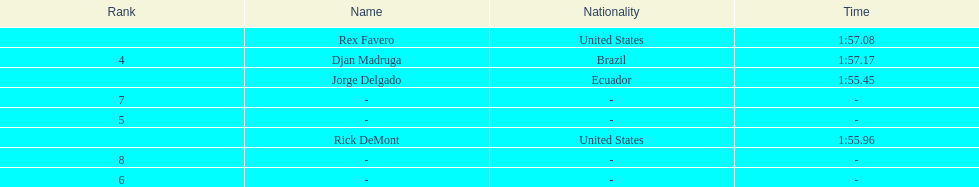Who finished with the top time? Jorge Delgado. Could you help me parse every detail presented in this table? {'header': ['Rank', 'Name', 'Nationality', 'Time'], 'rows': [['', 'Rex Favero', 'United States', '1:57.08'], ['4', 'Djan Madruga', 'Brazil', '1:57.17'], ['', 'Jorge Delgado', 'Ecuador', '1:55.45'], ['7', '-', '-', '-'], ['5', '-', '-', '-'], ['', 'Rick DeMont', 'United States', '1:55.96'], ['8', '-', '-', '-'], ['6', '-', '-', '-']]} 